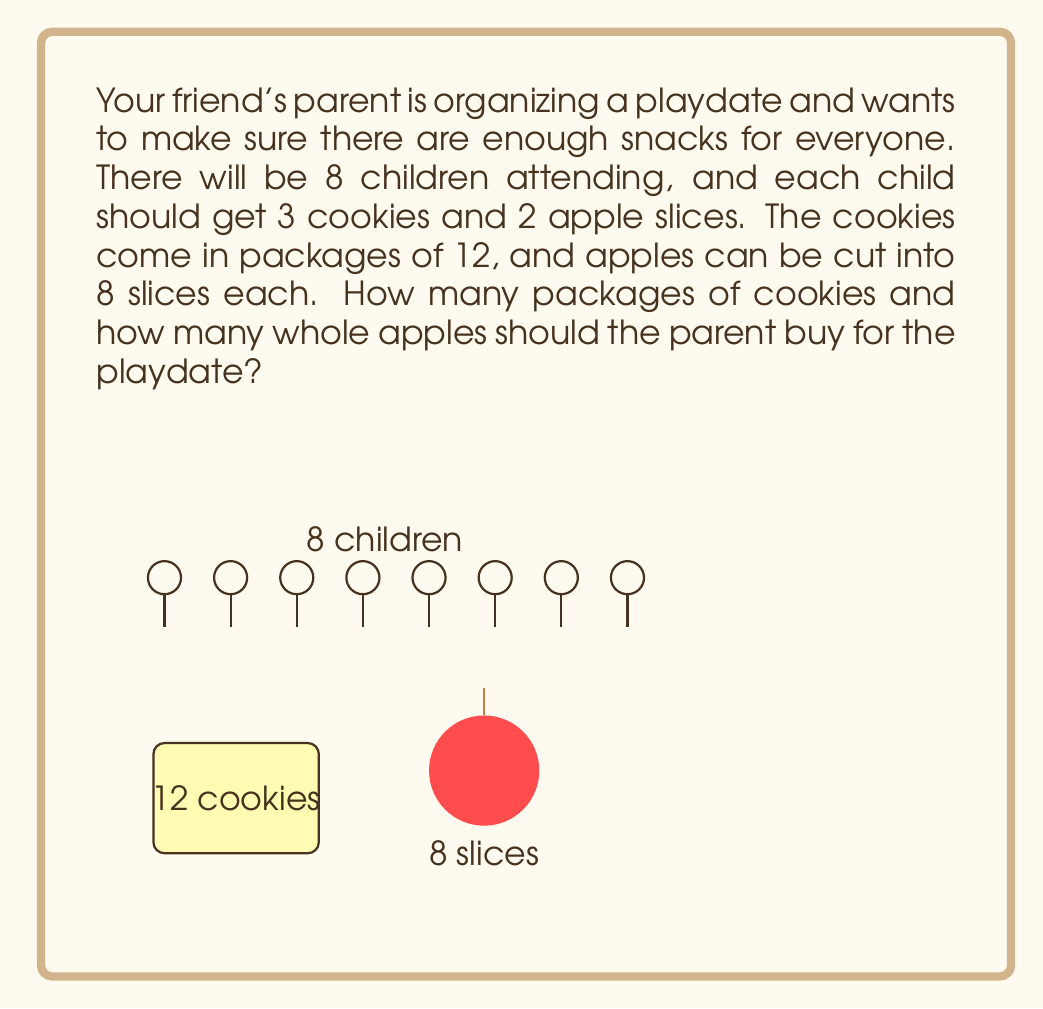Provide a solution to this math problem. Let's break this problem down step by step:

1. Calculate the total number of cookies needed:
   $$ \text{Total cookies} = \text{Number of children} \times \text{Cookies per child} $$
   $$ \text{Total cookies} = 8 \times 3 = 24 \text{ cookies} $$

2. Calculate the number of cookie packages needed:
   $$ \text{Cookie packages} = \ceil{\frac{\text{Total cookies}}{\text{Cookies per package}}} $$
   $$ \text{Cookie packages} = \ceil{\frac{24}{12}} = 2 \text{ packages} $$

3. Calculate the total number of apple slices needed:
   $$ \text{Total apple slices} = \text{Number of children} \times \text{Apple slices per child} $$
   $$ \text{Total apple slices} = 8 \times 2 = 16 \text{ slices} $$

4. Calculate the number of whole apples needed:
   $$ \text{Whole apples} = \ceil{\frac{\text{Total apple slices}}{\text{Slices per apple}}} $$
   $$ \text{Whole apples} = \ceil{\frac{16}{8}} = 2 \text{ apples} $$

Therefore, the parent should buy 2 packages of cookies and 2 whole apples for the playdate.
Answer: 2 cookie packages, 2 apples 